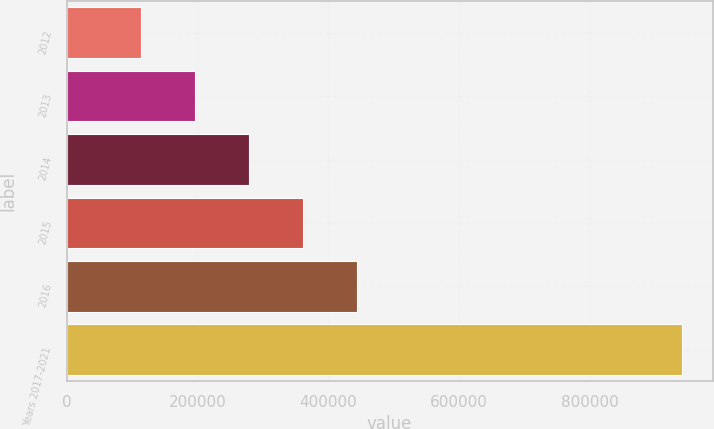Convert chart. <chart><loc_0><loc_0><loc_500><loc_500><bar_chart><fcel>2012<fcel>2013<fcel>2014<fcel>2015<fcel>2016<fcel>Years 2017-2021<nl><fcel>113075<fcel>195905<fcel>278735<fcel>361566<fcel>444396<fcel>941377<nl></chart> 